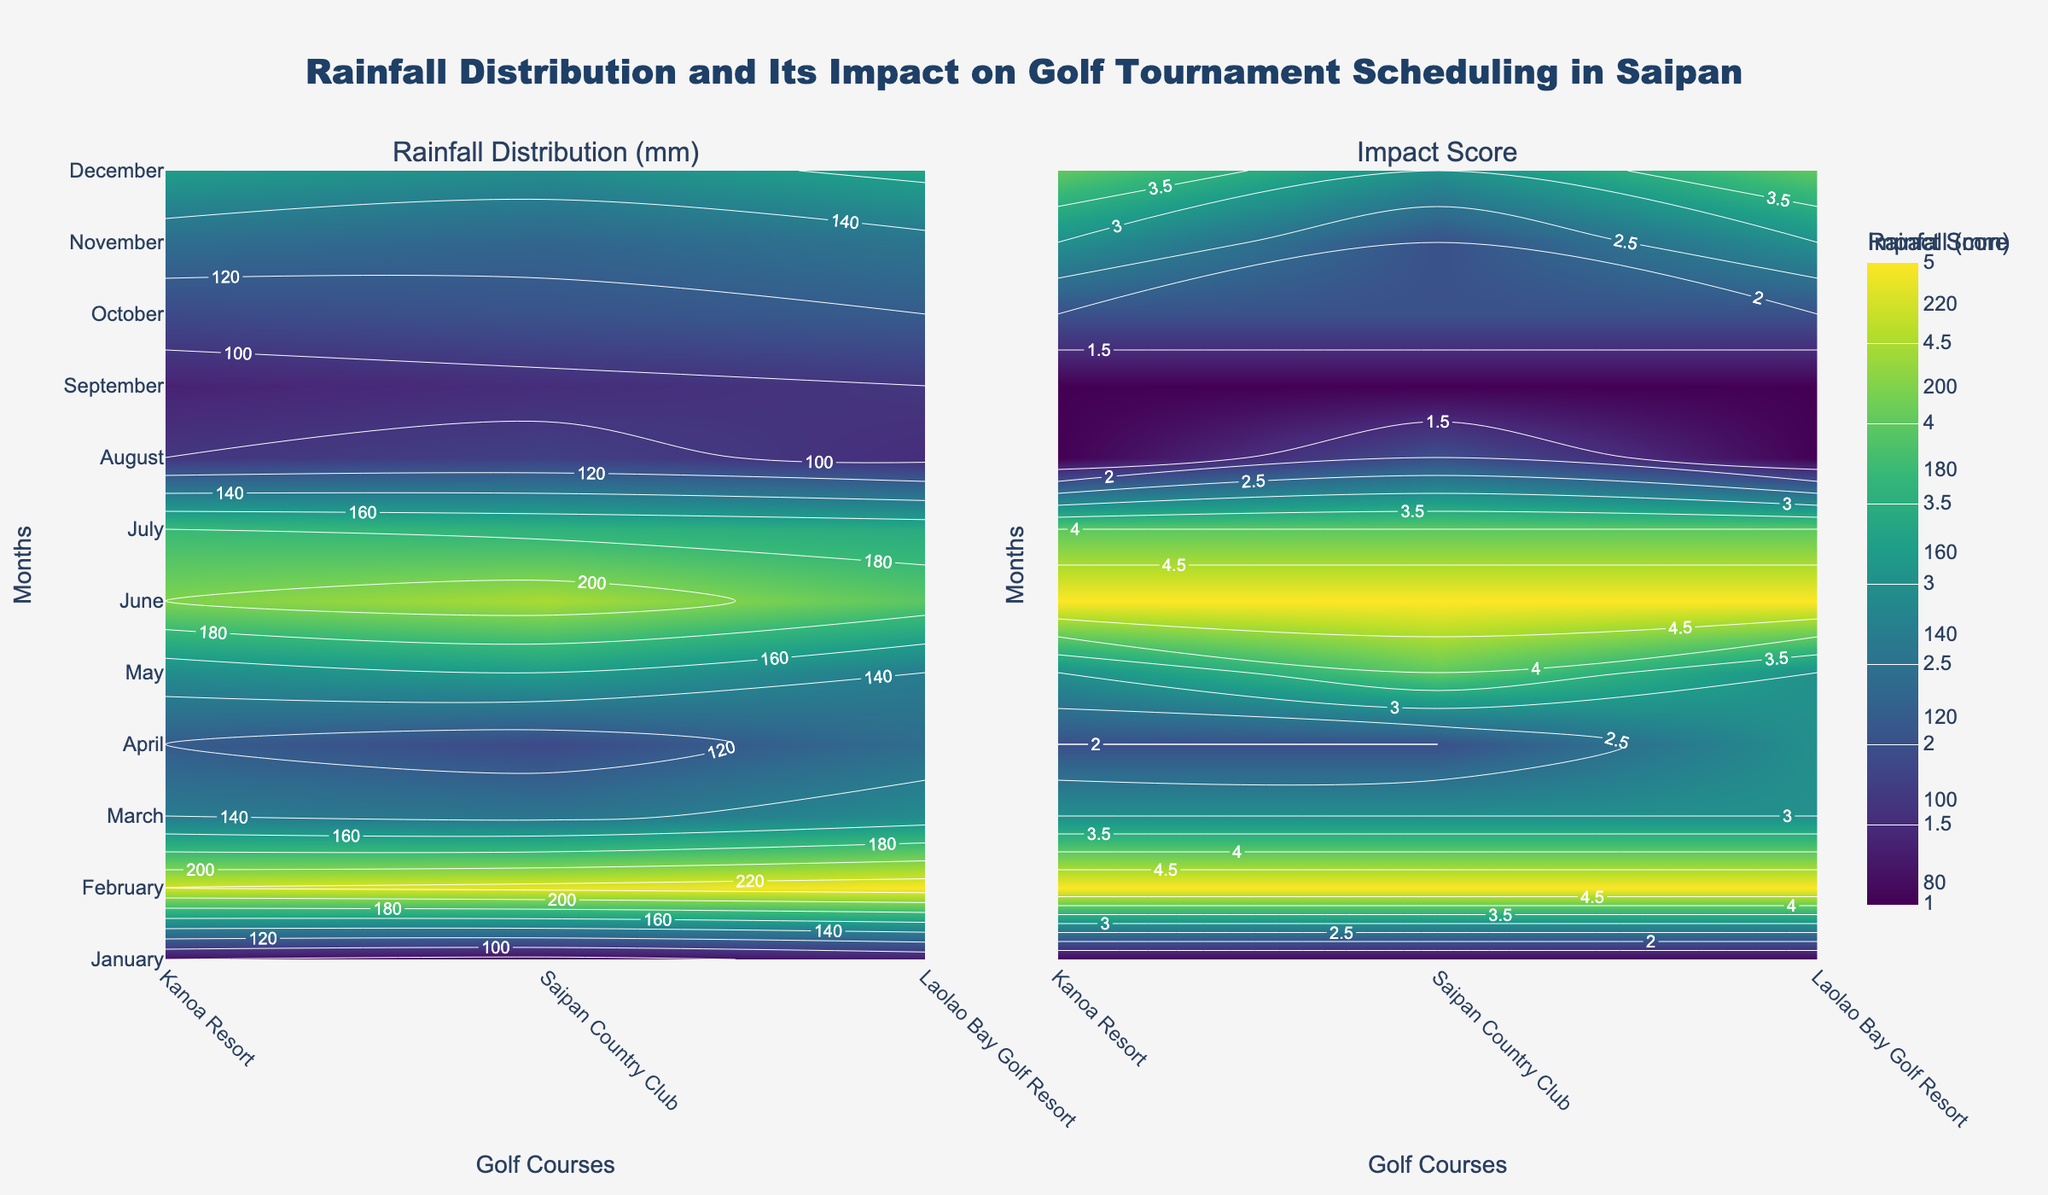What is the title of the figure? The title can be found at the top of the figure in a larger font size and distinctive color. It reads "Rainfall Distribution and Its Impact on Golf Tournament Scheduling in Saipan."
Answer: Rainfall Distribution and Its Impact on Golf Tournament Scheduling in Saipan Which month has the highest rainfall at Saipan Country Club? Look for the contour representing Saipan Country Club across the months on the Rainfall Distribution (mm) plot. Identify which month appears at the peak.
Answer: August How does the Impact Score at Laolao Bay Golf Resort in January compare to that in March? Compare the values on the Impact Score plot for Laolao Bay Golf Resort in January and March. January shows a score of 4, while March has a score of 2.
Answer: Higher in January During which month does Kanoa Resort experience the lowest rainfall? Look at the Rainfall Distribution (mm) plot, focusing on Kanoa Resort. Identify the lowest point for Kanoa Resort.
Answer: April What is the average rainfall across all locations in February? Locate February on the Rainfall Distribution plot and note the values for each location (120 mm for Kanoa Resort, 130 mm for Saipan Country Club, and 110 mm for Laolao Bay Golf Resort). Calculate the average: (120 + 130 + 110) / 3.
Answer: 120 mm What is the Impact Score for Saipan Country Club in July? Refer to the Impact Score plot and find July for Saipan Country Club. The contour label shows a value of 5.
Answer: 5 Which location has the smallest change in Impact Score from June to July? Examine the Impact Score across June and July for all locations. Calculate the difference for each: Kanoa Resort (1), Saipan Country Club (1), Laolao Bay Golf Resort (0).
Answer: Laolao Bay Golf Resort How does the rainfall in December compare between Kanoa Resort and Laolao Bay Golf Resort? Check the Rainfall Distribution (mm) plot for December. Kanoa Resort has 140 mm and Laolao Bay Golf Resort has 135 mm. Compare both values.
Answer: Kanoa Resort has more Which month shows the highest overall Impact Score across all locations? Check the Impact Score plot's contour labels for the highest values, which are consistently at the peak in July and August across all locations.
Answer: July and August 